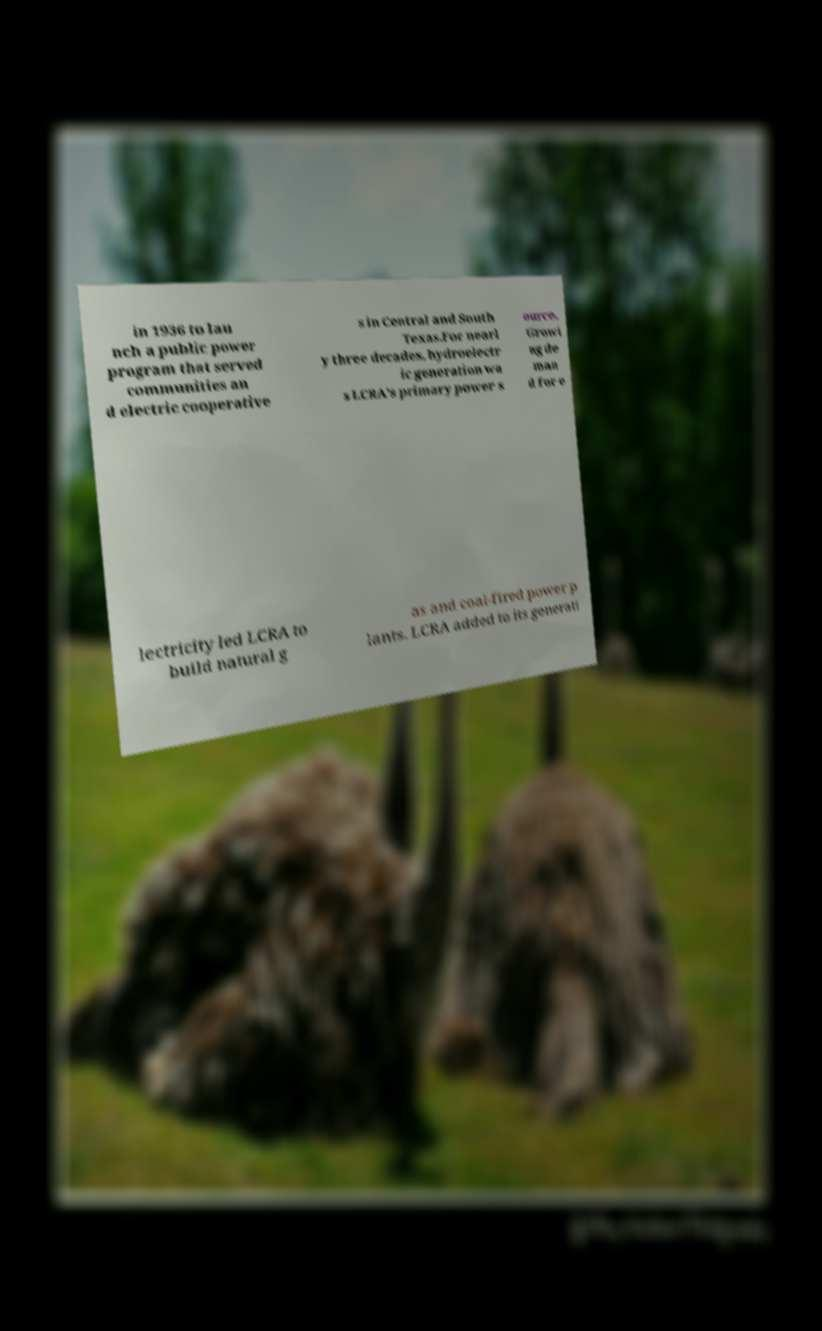Could you extract and type out the text from this image? in 1936 to lau nch a public power program that served communities an d electric cooperative s in Central and South Texas.For nearl y three decades, hydroelectr ic generation wa s LCRA's primary power s ource. Growi ng de man d for e lectricity led LCRA to build natural g as and coal-fired power p lants. LCRA added to its generati 